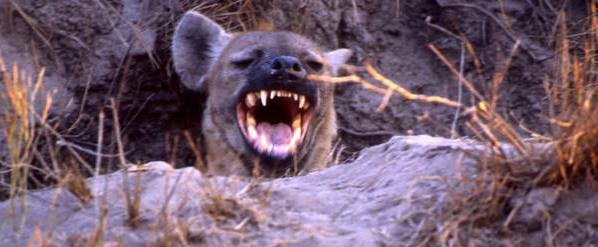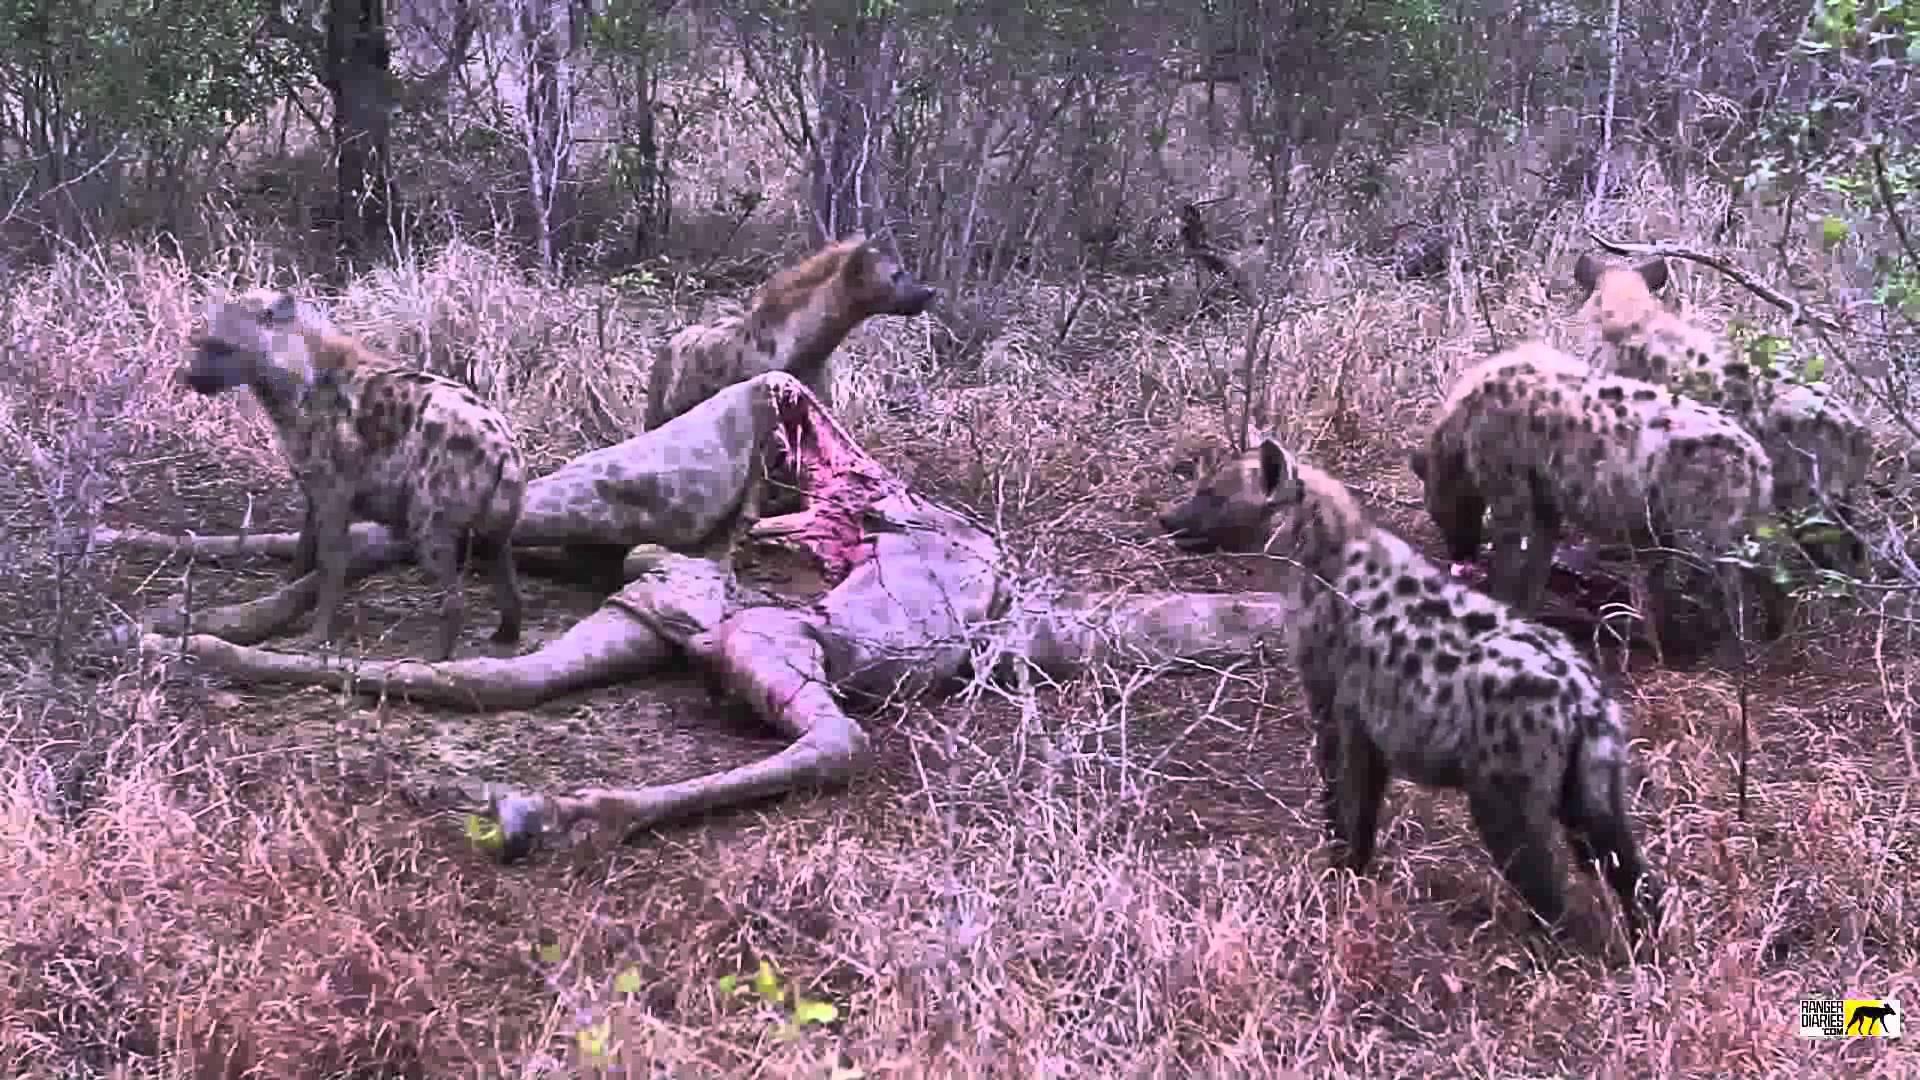The first image is the image on the left, the second image is the image on the right. For the images shown, is this caption "An image shows a hyena near the carcass of a giraffe with its spotted hooved legs visible." true? Answer yes or no. Yes. The first image is the image on the left, the second image is the image on the right. Examine the images to the left and right. Is the description "One of the images features only one hyena." accurate? Answer yes or no. Yes. 